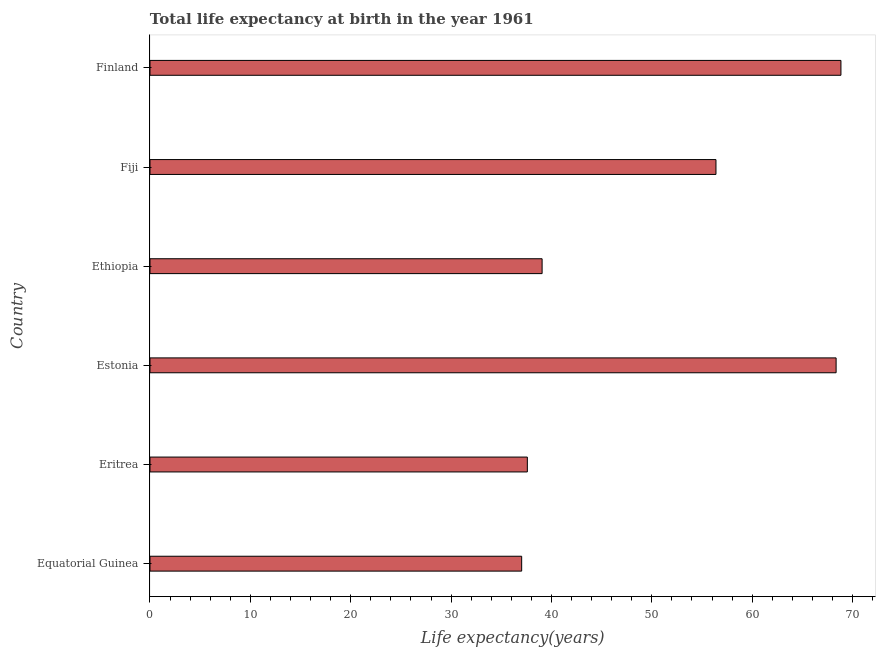Does the graph contain any zero values?
Give a very brief answer. No. Does the graph contain grids?
Your answer should be compact. No. What is the title of the graph?
Give a very brief answer. Total life expectancy at birth in the year 1961. What is the label or title of the X-axis?
Give a very brief answer. Life expectancy(years). What is the life expectancy at birth in Estonia?
Make the answer very short. 68.36. Across all countries, what is the maximum life expectancy at birth?
Your answer should be very brief. 68.84. Across all countries, what is the minimum life expectancy at birth?
Your answer should be very brief. 37.03. In which country was the life expectancy at birth maximum?
Your response must be concise. Finland. In which country was the life expectancy at birth minimum?
Offer a terse response. Equatorial Guinea. What is the sum of the life expectancy at birth?
Your answer should be very brief. 307.3. What is the difference between the life expectancy at birth in Fiji and Finland?
Offer a terse response. -12.45. What is the average life expectancy at birth per country?
Your response must be concise. 51.22. What is the median life expectancy at birth?
Offer a very short reply. 47.73. What is the ratio of the life expectancy at birth in Estonia to that in Ethiopia?
Give a very brief answer. 1.75. Is the difference between the life expectancy at birth in Estonia and Fiji greater than the difference between any two countries?
Your response must be concise. No. What is the difference between the highest and the second highest life expectancy at birth?
Offer a very short reply. 0.48. What is the difference between the highest and the lowest life expectancy at birth?
Make the answer very short. 31.81. In how many countries, is the life expectancy at birth greater than the average life expectancy at birth taken over all countries?
Offer a terse response. 3. Are all the bars in the graph horizontal?
Ensure brevity in your answer.  Yes. What is the difference between two consecutive major ticks on the X-axis?
Make the answer very short. 10. What is the Life expectancy(years) in Equatorial Guinea?
Provide a succinct answer. 37.03. What is the Life expectancy(years) in Eritrea?
Keep it short and to the point. 37.6. What is the Life expectancy(years) in Estonia?
Keep it short and to the point. 68.36. What is the Life expectancy(years) of Ethiopia?
Your answer should be very brief. 39.07. What is the Life expectancy(years) of Fiji?
Ensure brevity in your answer.  56.39. What is the Life expectancy(years) of Finland?
Give a very brief answer. 68.84. What is the difference between the Life expectancy(years) in Equatorial Guinea and Eritrea?
Offer a very short reply. -0.57. What is the difference between the Life expectancy(years) in Equatorial Guinea and Estonia?
Your answer should be very brief. -31.33. What is the difference between the Life expectancy(years) in Equatorial Guinea and Ethiopia?
Give a very brief answer. -2.04. What is the difference between the Life expectancy(years) in Equatorial Guinea and Fiji?
Offer a terse response. -19.36. What is the difference between the Life expectancy(years) in Equatorial Guinea and Finland?
Offer a very short reply. -31.81. What is the difference between the Life expectancy(years) in Eritrea and Estonia?
Your answer should be compact. -30.76. What is the difference between the Life expectancy(years) in Eritrea and Ethiopia?
Provide a short and direct response. -1.47. What is the difference between the Life expectancy(years) in Eritrea and Fiji?
Give a very brief answer. -18.79. What is the difference between the Life expectancy(years) in Eritrea and Finland?
Provide a short and direct response. -31.25. What is the difference between the Life expectancy(years) in Estonia and Ethiopia?
Ensure brevity in your answer.  29.29. What is the difference between the Life expectancy(years) in Estonia and Fiji?
Provide a short and direct response. 11.97. What is the difference between the Life expectancy(years) in Estonia and Finland?
Your answer should be compact. -0.48. What is the difference between the Life expectancy(years) in Ethiopia and Fiji?
Your answer should be compact. -17.32. What is the difference between the Life expectancy(years) in Ethiopia and Finland?
Your answer should be compact. -29.77. What is the difference between the Life expectancy(years) in Fiji and Finland?
Provide a short and direct response. -12.45. What is the ratio of the Life expectancy(years) in Equatorial Guinea to that in Estonia?
Your response must be concise. 0.54. What is the ratio of the Life expectancy(years) in Equatorial Guinea to that in Ethiopia?
Provide a short and direct response. 0.95. What is the ratio of the Life expectancy(years) in Equatorial Guinea to that in Fiji?
Ensure brevity in your answer.  0.66. What is the ratio of the Life expectancy(years) in Equatorial Guinea to that in Finland?
Keep it short and to the point. 0.54. What is the ratio of the Life expectancy(years) in Eritrea to that in Estonia?
Provide a short and direct response. 0.55. What is the ratio of the Life expectancy(years) in Eritrea to that in Fiji?
Your response must be concise. 0.67. What is the ratio of the Life expectancy(years) in Eritrea to that in Finland?
Your answer should be very brief. 0.55. What is the ratio of the Life expectancy(years) in Estonia to that in Fiji?
Give a very brief answer. 1.21. What is the ratio of the Life expectancy(years) in Ethiopia to that in Fiji?
Give a very brief answer. 0.69. What is the ratio of the Life expectancy(years) in Ethiopia to that in Finland?
Your answer should be very brief. 0.57. What is the ratio of the Life expectancy(years) in Fiji to that in Finland?
Your response must be concise. 0.82. 